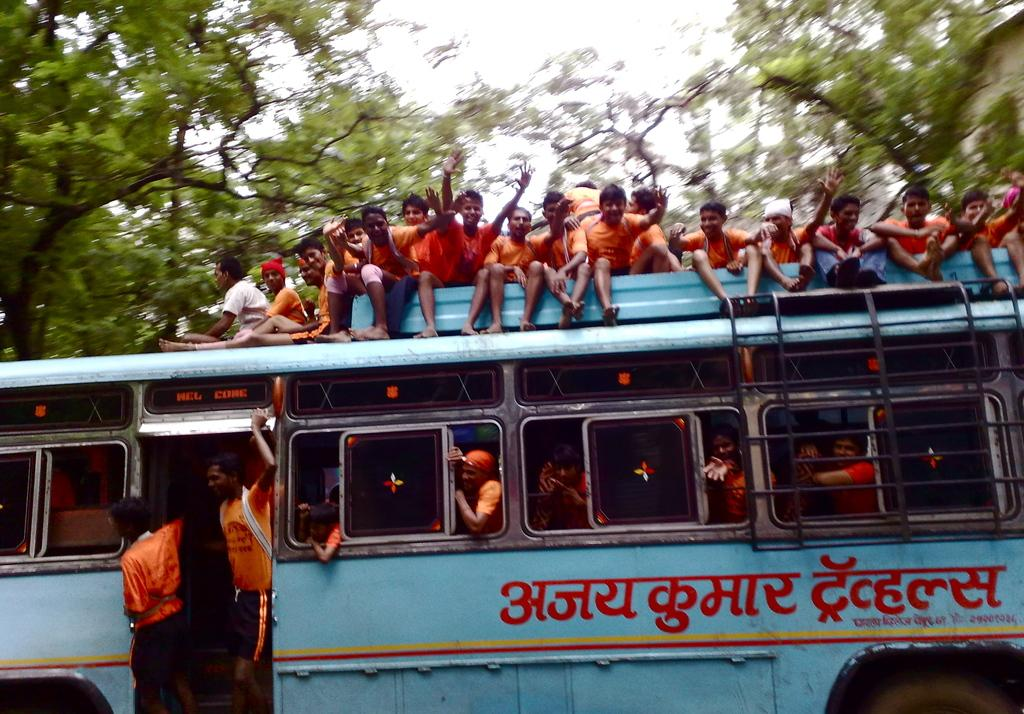What is the main subject of the image? There is a bus in the image. Can you describe the people in the image? There are people inside the bus and people on the bus. What can be seen in the background of the image? There are trees and the sky visible in the background of the image. What type of twig can be seen hanging from the bus in the image? There is no twig hanging from the bus in the image. What type of wilderness can be seen in the background of the image? There is no wilderness visible in the background of the image; only trees and the sky can be seen. 